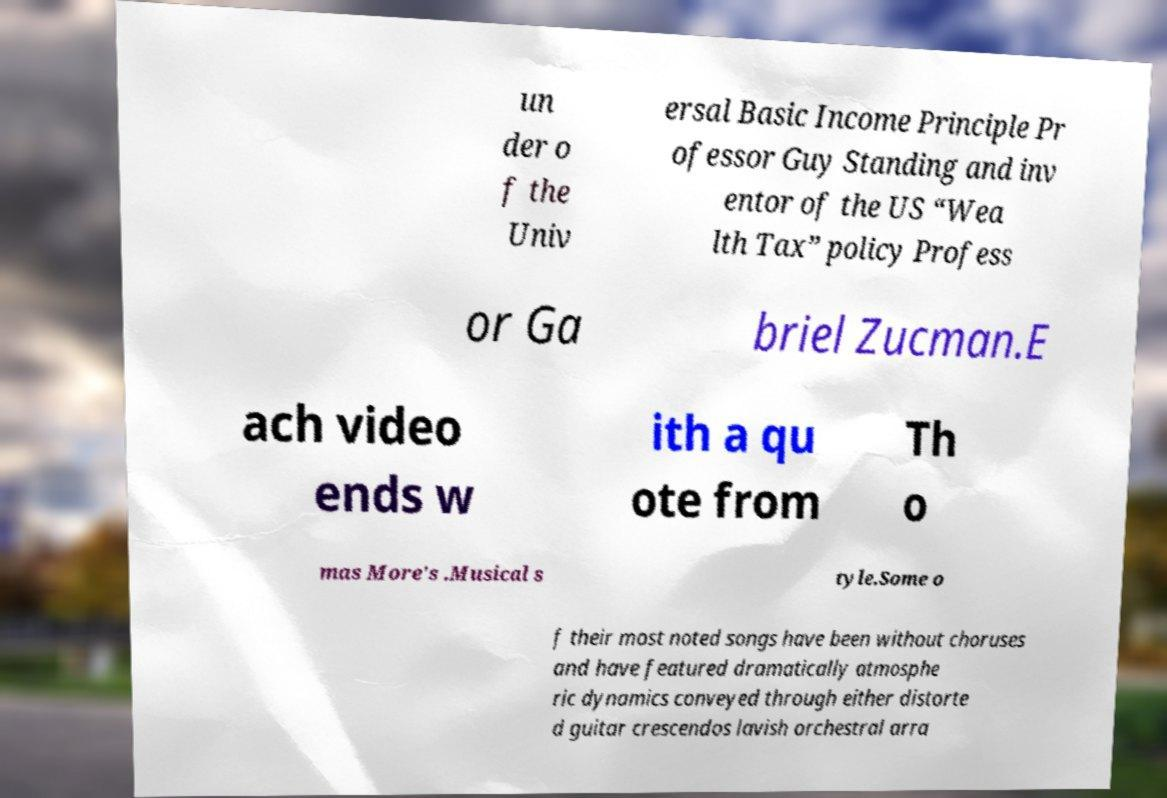For documentation purposes, I need the text within this image transcribed. Could you provide that? un der o f the Univ ersal Basic Income Principle Pr ofessor Guy Standing and inv entor of the US “Wea lth Tax” policy Profess or Ga briel Zucman.E ach video ends w ith a qu ote from Th o mas More's .Musical s tyle.Some o f their most noted songs have been without choruses and have featured dramatically atmosphe ric dynamics conveyed through either distorte d guitar crescendos lavish orchestral arra 